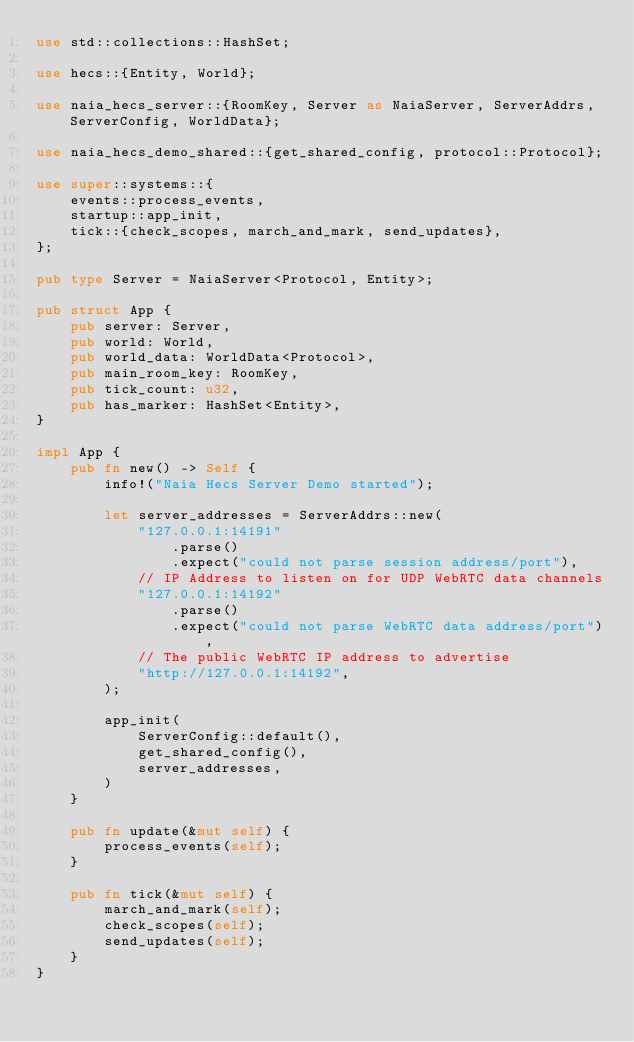Convert code to text. <code><loc_0><loc_0><loc_500><loc_500><_Rust_>use std::collections::HashSet;

use hecs::{Entity, World};

use naia_hecs_server::{RoomKey, Server as NaiaServer, ServerAddrs, ServerConfig, WorldData};

use naia_hecs_demo_shared::{get_shared_config, protocol::Protocol};

use super::systems::{
    events::process_events,
    startup::app_init,
    tick::{check_scopes, march_and_mark, send_updates},
};

pub type Server = NaiaServer<Protocol, Entity>;

pub struct App {
    pub server: Server,
    pub world: World,
    pub world_data: WorldData<Protocol>,
    pub main_room_key: RoomKey,
    pub tick_count: u32,
    pub has_marker: HashSet<Entity>,
}

impl App {
    pub fn new() -> Self {
        info!("Naia Hecs Server Demo started");

        let server_addresses = ServerAddrs::new(
            "127.0.0.1:14191"
                .parse()
                .expect("could not parse session address/port"),
            // IP Address to listen on for UDP WebRTC data channels
            "127.0.0.1:14192"
                .parse()
                .expect("could not parse WebRTC data address/port"),
            // The public WebRTC IP address to advertise
            "http://127.0.0.1:14192",
        );

        app_init(
            ServerConfig::default(),
            get_shared_config(),
            server_addresses,
        )
    }

    pub fn update(&mut self) {
        process_events(self);
    }

    pub fn tick(&mut self) {
        march_and_mark(self);
        check_scopes(self);
        send_updates(self);
    }
}
</code> 